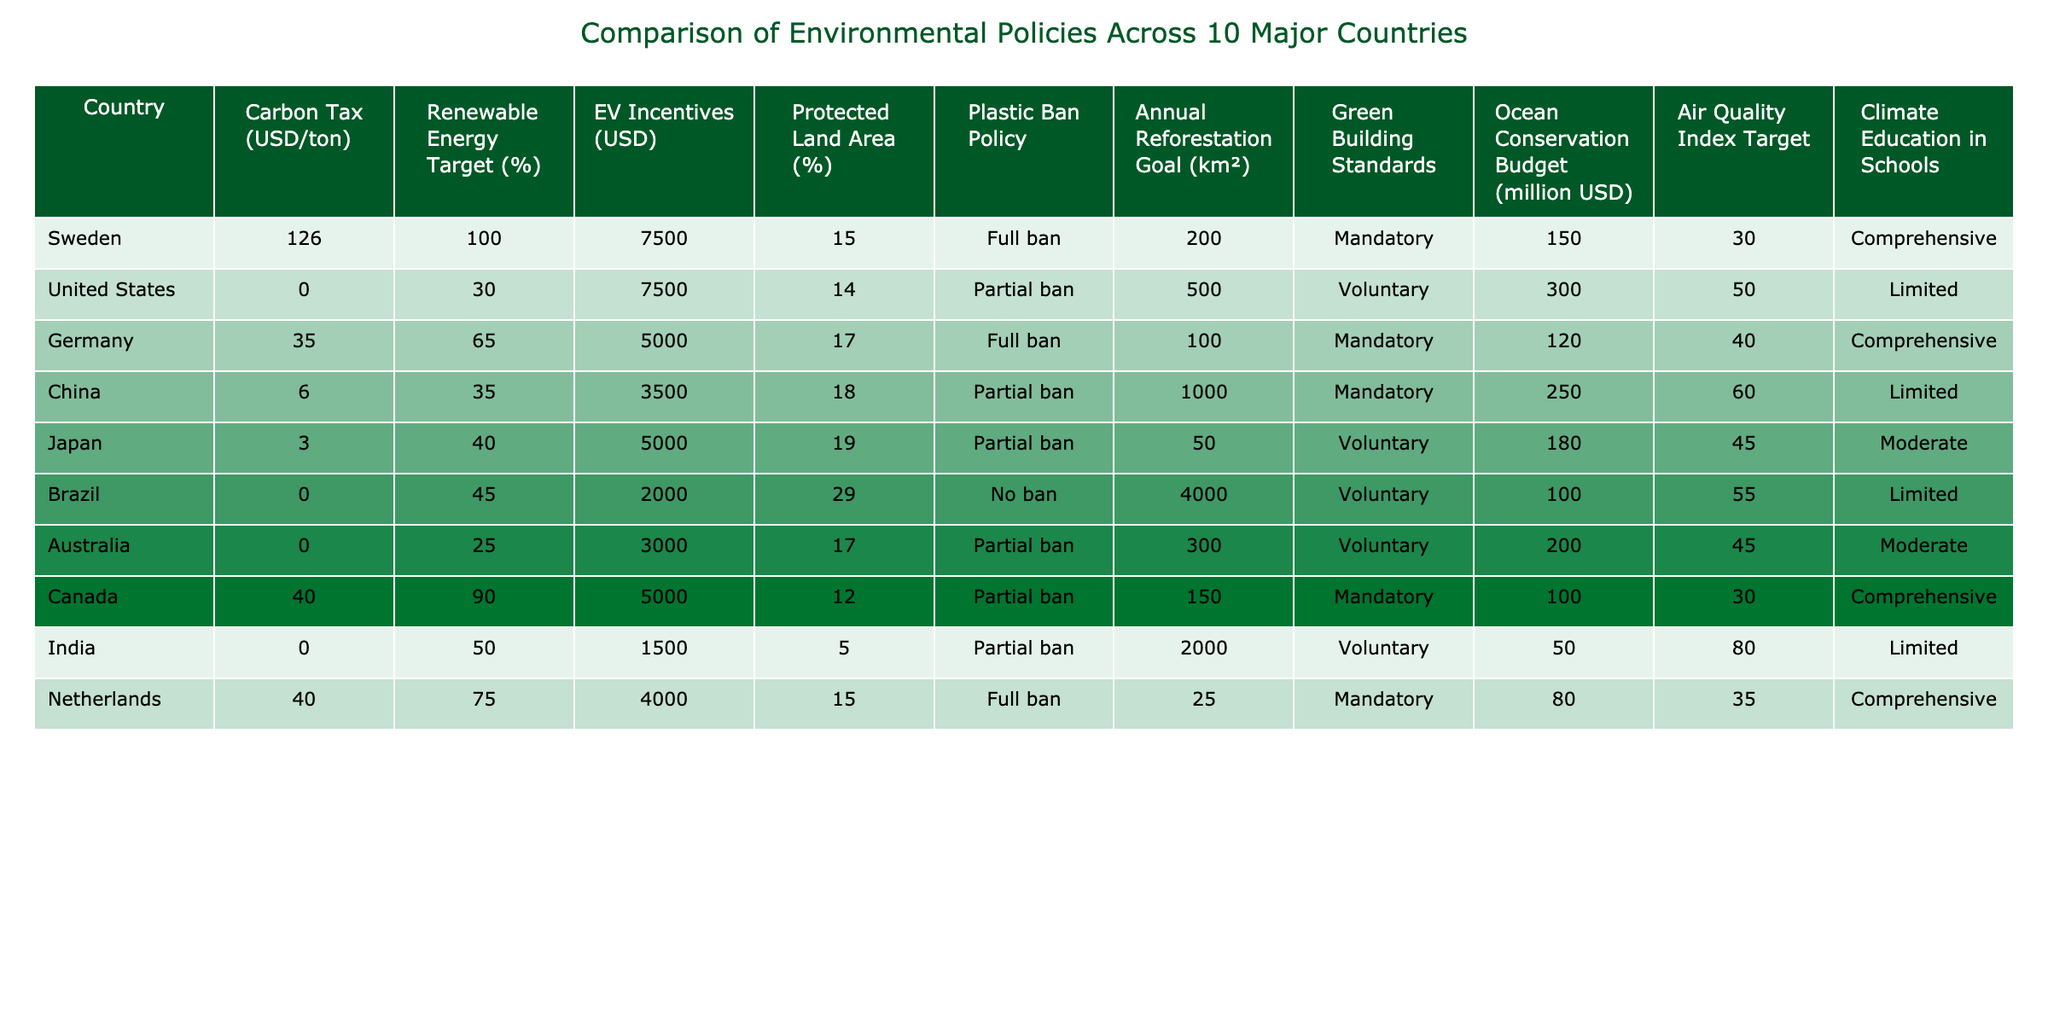What is the carbon tax rate in Sweden? The table indicates that the carbon tax rate assigned to Sweden is listed as 126 USD/ton.
Answer: 126 USD/ton Which country has the highest renewable energy target percentage? By examining the renewable energy target column, Sweden has a target of 100%, which is the highest among the countries listed.
Answer: Sweden (100%) How much is the ocean conservation budget for Germany? The table shows that Germany's ocean conservation budget is 120 million USD.
Answer: 120 million USD Are all countries listed implementing a full ban on plastic? Reviewing the plastic ban policy column reveals that only Sweden, Germany, and the Netherlands have a full ban. Therefore, not all countries are implementing it.
Answer: No Which country has the largest protected land area percentage and how much is it? Brazil has the largest protected land area percentage at 29%, which can be found in the protected land area column.
Answer: 29% What is the average carbon tax of the countries listed? The sum of the carbon taxes for the countries (126 + 0 + 35 + 6 + 3 + 0 + 0 + 40 + 0 + 40) equals 250, and dividing by the number of countries (10) gives an average of 25.
Answer: 25 USD/ton Which two countries have the same EV incentives amount? By examining the EV incentives column, the table shows that the United States and Japan both have an EV incentive of 7500 USD.
Answer: United States and Japan What is the air quality index target for Brazil? Looking at the air quality index target column, Brazil's target is 55, as stated in the table.
Answer: 55 Which country has the highest annual reforestation goal in km²? The annual reforestation goal column indicates that Brazil has the highest goal at 4000 km².
Answer: Brazil (4000 km²) Which country has comprehensive climate education in schools and a mandatory green building standard? Both Sweden and Canada have comprehensive climate education and a mandatory green building standard.
Answer: Sweden and Canada 